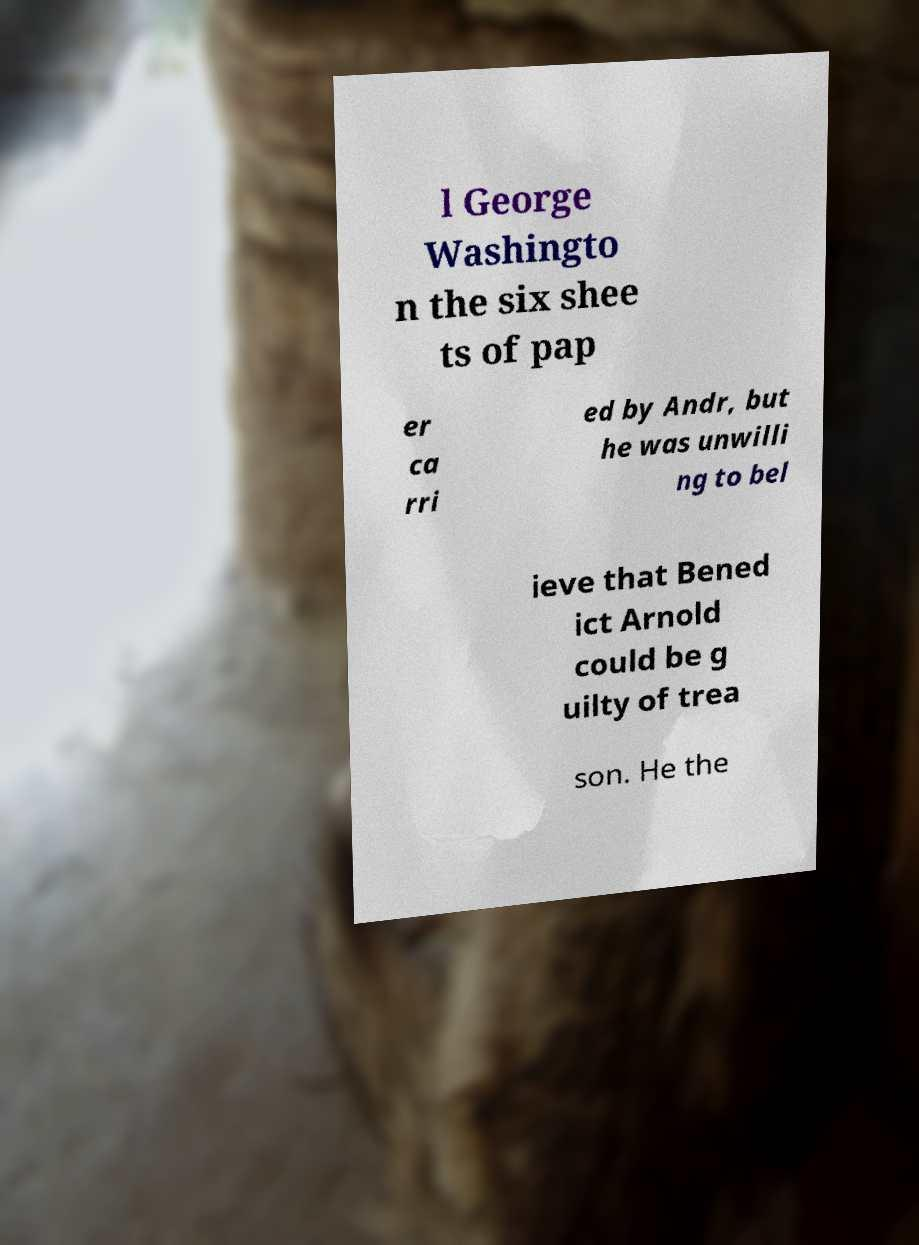There's text embedded in this image that I need extracted. Can you transcribe it verbatim? l George Washingto n the six shee ts of pap er ca rri ed by Andr, but he was unwilli ng to bel ieve that Bened ict Arnold could be g uilty of trea son. He the 